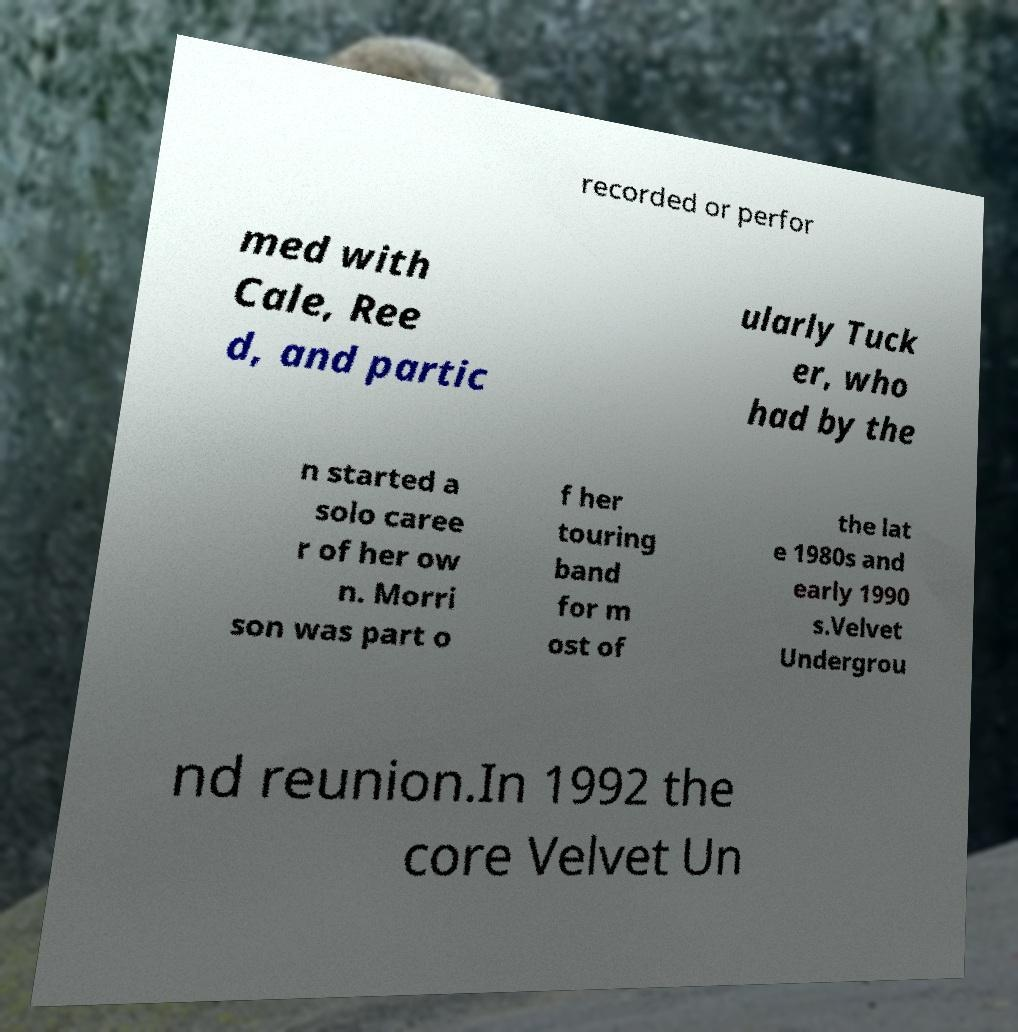I need the written content from this picture converted into text. Can you do that? recorded or perfor med with Cale, Ree d, and partic ularly Tuck er, who had by the n started a solo caree r of her ow n. Morri son was part o f her touring band for m ost of the lat e 1980s and early 1990 s.Velvet Undergrou nd reunion.In 1992 the core Velvet Un 